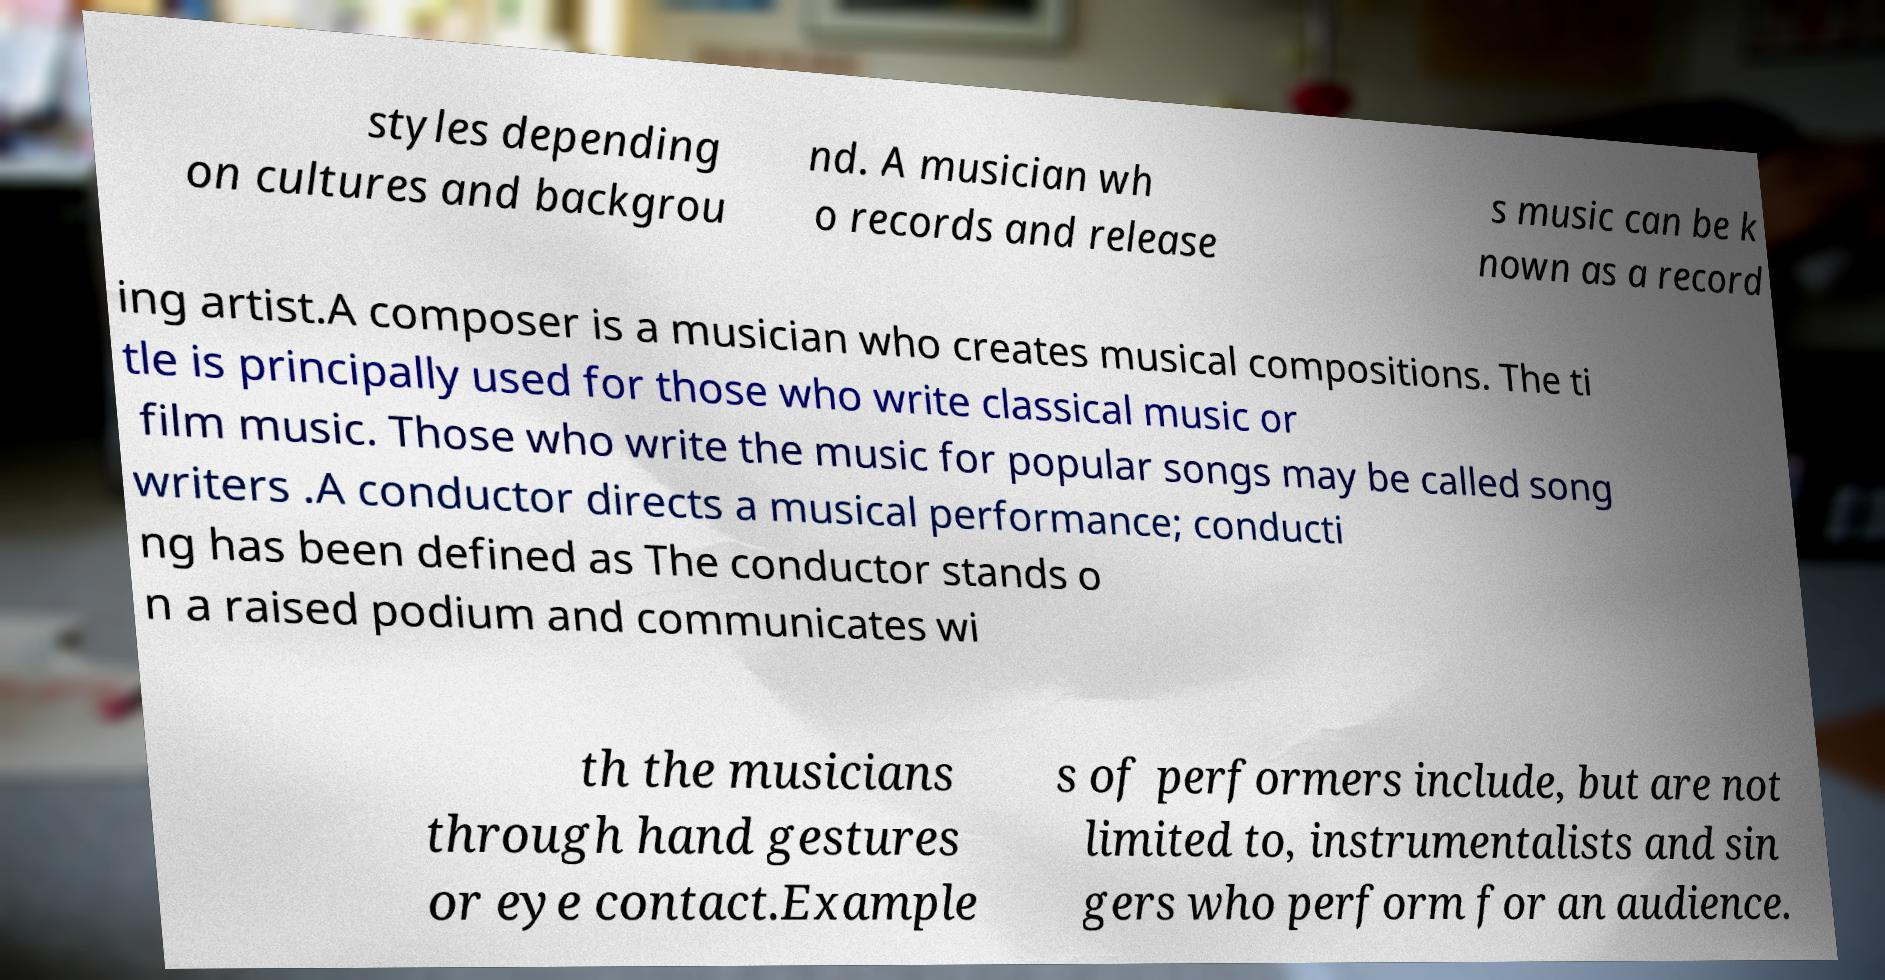Please read and relay the text visible in this image. What does it say? styles depending on cultures and backgrou nd. A musician wh o records and release s music can be k nown as a record ing artist.A composer is a musician who creates musical compositions. The ti tle is principally used for those who write classical music or film music. Those who write the music for popular songs may be called song writers .A conductor directs a musical performance; conducti ng has been defined as The conductor stands o n a raised podium and communicates wi th the musicians through hand gestures or eye contact.Example s of performers include, but are not limited to, instrumentalists and sin gers who perform for an audience. 